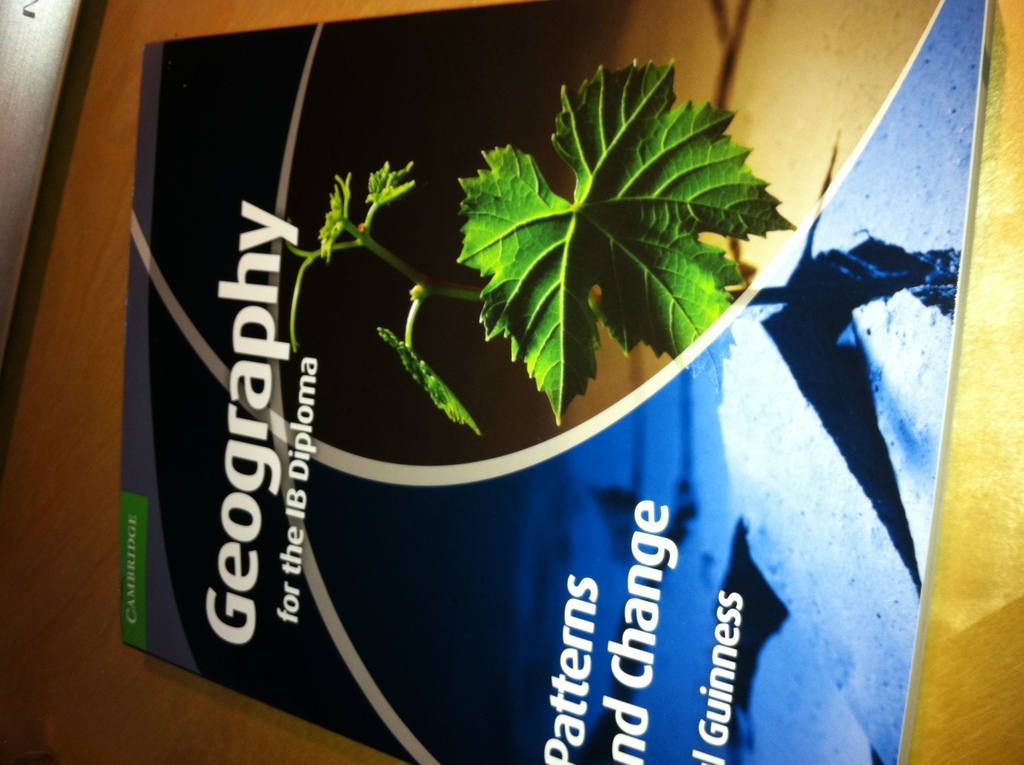Provide a one-sentence caption for the provided image. The image features the cover of a 'Geography for the IB Diploma' book by Guinness, showcasing a leaf and its shadow projected on a geographic contour map, highlighting themes of natural and human geography. 